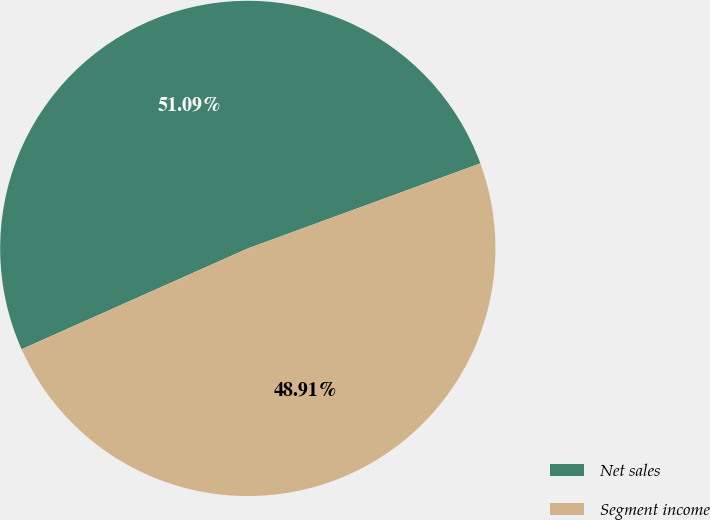Convert chart to OTSL. <chart><loc_0><loc_0><loc_500><loc_500><pie_chart><fcel>Net sales<fcel>Segment income<nl><fcel>51.09%<fcel>48.91%<nl></chart> 